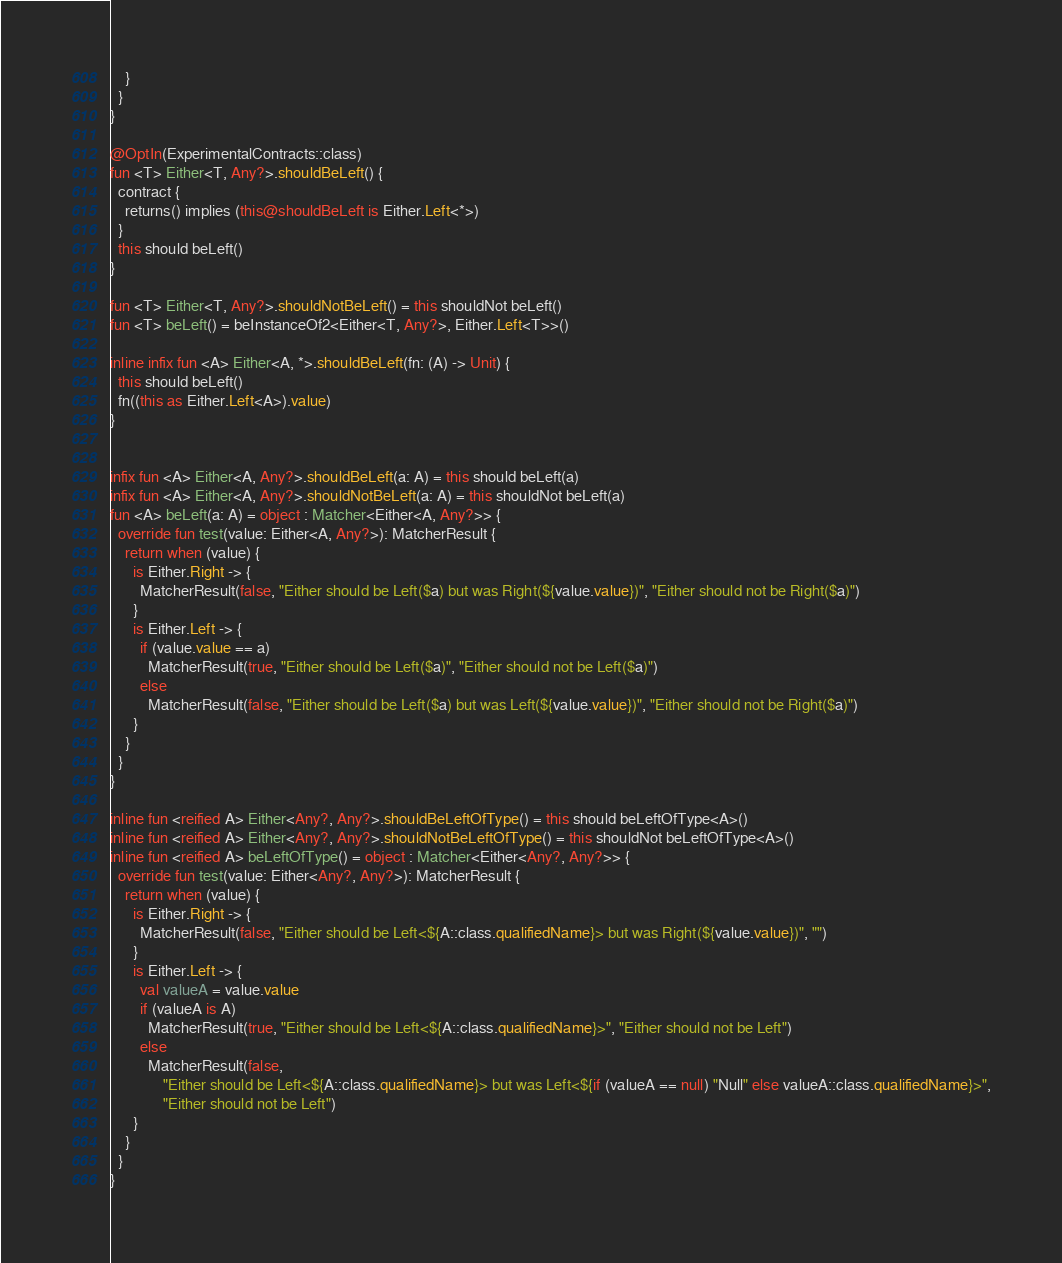<code> <loc_0><loc_0><loc_500><loc_500><_Kotlin_>    }
  }
}

@OptIn(ExperimentalContracts::class)
fun <T> Either<T, Any?>.shouldBeLeft() {
  contract {
    returns() implies (this@shouldBeLeft is Either.Left<*>)
  }
  this should beLeft()
}

fun <T> Either<T, Any?>.shouldNotBeLeft() = this shouldNot beLeft()
fun <T> beLeft() = beInstanceOf2<Either<T, Any?>, Either.Left<T>>()

inline infix fun <A> Either<A, *>.shouldBeLeft(fn: (A) -> Unit) {
  this should beLeft()
  fn((this as Either.Left<A>).value)
}


infix fun <A> Either<A, Any?>.shouldBeLeft(a: A) = this should beLeft(a)
infix fun <A> Either<A, Any?>.shouldNotBeLeft(a: A) = this shouldNot beLeft(a)
fun <A> beLeft(a: A) = object : Matcher<Either<A, Any?>> {
  override fun test(value: Either<A, Any?>): MatcherResult {
    return when (value) {
      is Either.Right -> {
        MatcherResult(false, "Either should be Left($a) but was Right(${value.value})", "Either should not be Right($a)")
      }
      is Either.Left -> {
        if (value.value == a)
          MatcherResult(true, "Either should be Left($a)", "Either should not be Left($a)")
        else
          MatcherResult(false, "Either should be Left($a) but was Left(${value.value})", "Either should not be Right($a)")
      }
    }
  }
}

inline fun <reified A> Either<Any?, Any?>.shouldBeLeftOfType() = this should beLeftOfType<A>()
inline fun <reified A> Either<Any?, Any?>.shouldNotBeLeftOfType() = this shouldNot beLeftOfType<A>()
inline fun <reified A> beLeftOfType() = object : Matcher<Either<Any?, Any?>> {
  override fun test(value: Either<Any?, Any?>): MatcherResult {
    return when (value) {
      is Either.Right -> {
        MatcherResult(false, "Either should be Left<${A::class.qualifiedName}> but was Right(${value.value})", "")
      }
      is Either.Left -> {
        val valueA = value.value
        if (valueA is A)
          MatcherResult(true, "Either should be Left<${A::class.qualifiedName}>", "Either should not be Left")
        else
          MatcherResult(false,
              "Either should be Left<${A::class.qualifiedName}> but was Left<${if (valueA == null) "Null" else valueA::class.qualifiedName}>",
              "Either should not be Left")
      }
    }
  }
}
</code> 